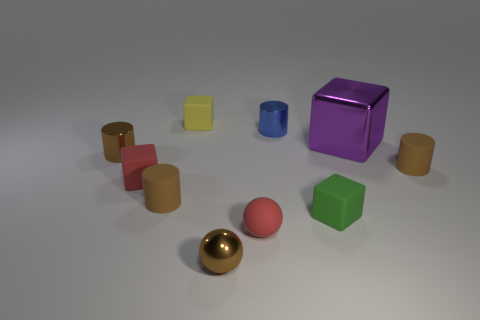Subtract all gray balls. How many brown cylinders are left? 3 Subtract all yellow blocks. How many blocks are left? 3 Subtract all blue cylinders. How many cylinders are left? 3 Subtract all red cylinders. Subtract all gray blocks. How many cylinders are left? 4 Subtract all cylinders. How many objects are left? 6 Subtract all large cubes. Subtract all balls. How many objects are left? 7 Add 8 green objects. How many green objects are left? 9 Add 9 large shiny cylinders. How many large shiny cylinders exist? 9 Subtract 1 purple blocks. How many objects are left? 9 